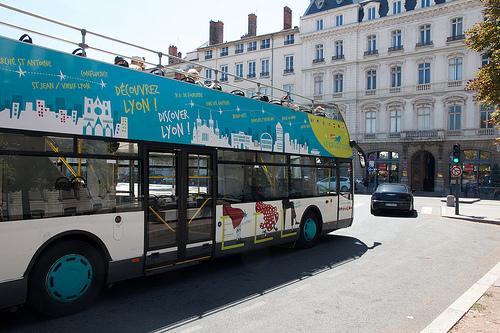What is significant about the wheels of the bus in the image? One bus wheel has a blue hubcap, while the other has a black wheel and a blue hubcap combination. What kind of vehicle is parked along the street in the image? There is a white car parked along the street in the image. How many chimneys can be observed on the building in the image? There are numerous chimneys on top of the large white building. Enumerate the different types of doors observed on the bus. The bus has a back exit passenger door and a front entrance/exit passenger door, both with black frames. Describe the general sentiment of the image. The image has a lively and bustling sentiment, with vehicles and pedestrians moving through a city landscape. Mention one unique feature about the large white building in the image. The large white building has several chimneys on its roof. Provide a brief description of the main focus of the image. A white and green double-decker bus with people sitting on the top level, driving through a city street with surrounding buildings and vehicles. Count and provide the total number of vehicles in the image. There are 4 vehicles in the image: a white & green double-decker bus, a dark gray car, a white car, and a black car. Describe the color and condition of the traffic light in the image. The traffic light is shining green, indicating that vehicles can proceed through the intersection. Analyze the interaction between the bus and the traffic light. The double-decker bus is approaching an intersection where the traffic light is shining green, signaling the bus to proceed through the intersection. 